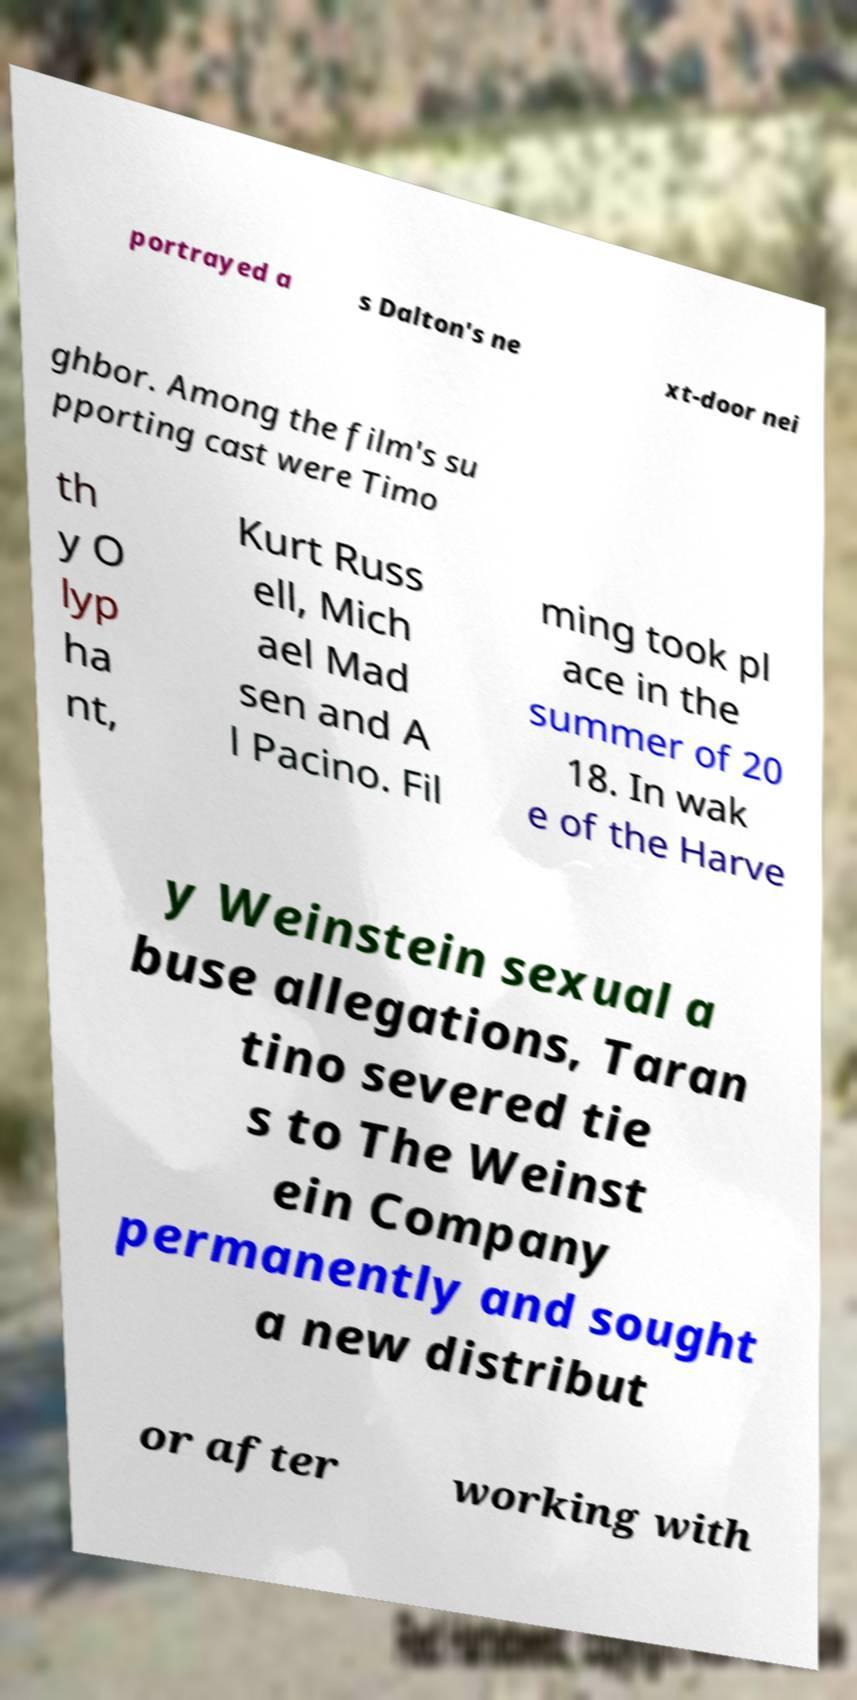Can you read and provide the text displayed in the image?This photo seems to have some interesting text. Can you extract and type it out for me? portrayed a s Dalton's ne xt-door nei ghbor. Among the film's su pporting cast were Timo th y O lyp ha nt, Kurt Russ ell, Mich ael Mad sen and A l Pacino. Fil ming took pl ace in the summer of 20 18. In wak e of the Harve y Weinstein sexual a buse allegations, Taran tino severed tie s to The Weinst ein Company permanently and sought a new distribut or after working with 